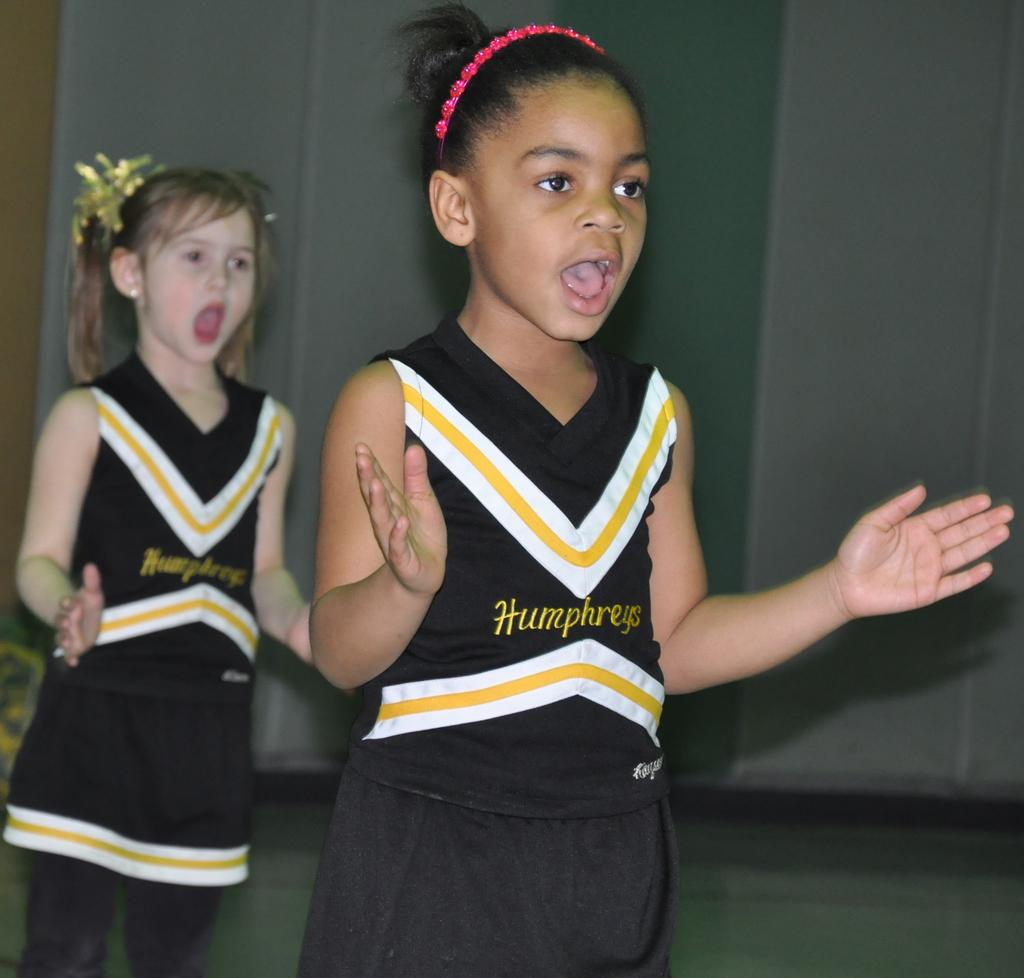<image>
Relay a brief, clear account of the picture shown. Two girls dressed in Humphreys cheerleading outfits are doing a routine. 